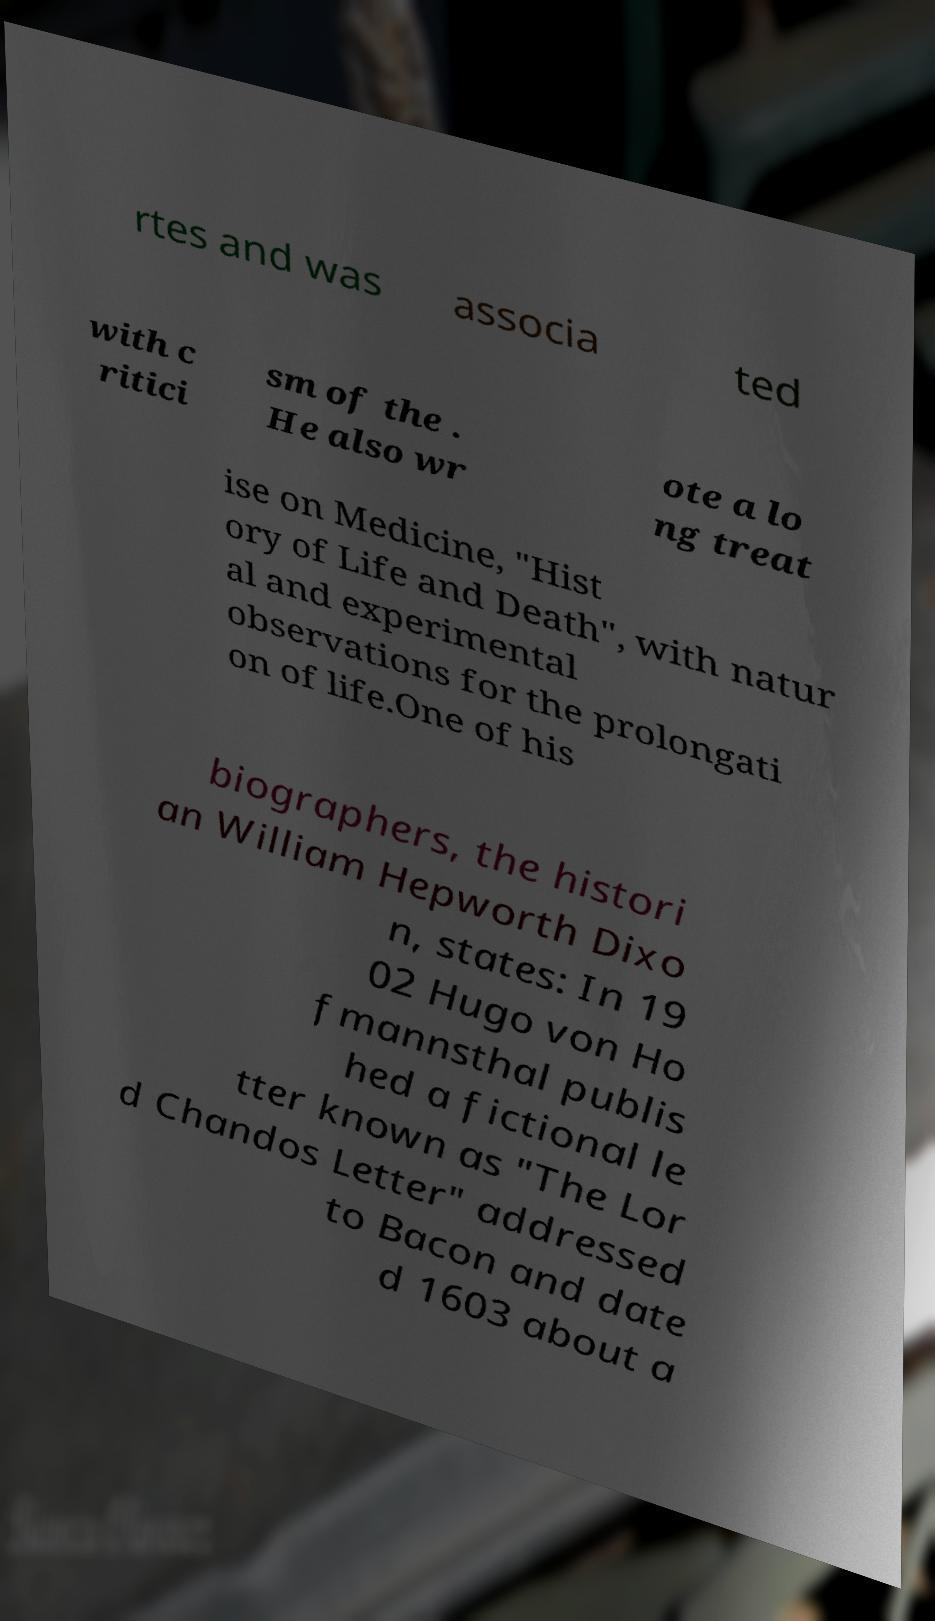Please identify and transcribe the text found in this image. rtes and was associa ted with c ritici sm of the . He also wr ote a lo ng treat ise on Medicine, "Hist ory of Life and Death", with natur al and experimental observations for the prolongati on of life.One of his biographers, the histori an William Hepworth Dixo n, states: In 19 02 Hugo von Ho fmannsthal publis hed a fictional le tter known as "The Lor d Chandos Letter" addressed to Bacon and date d 1603 about a 